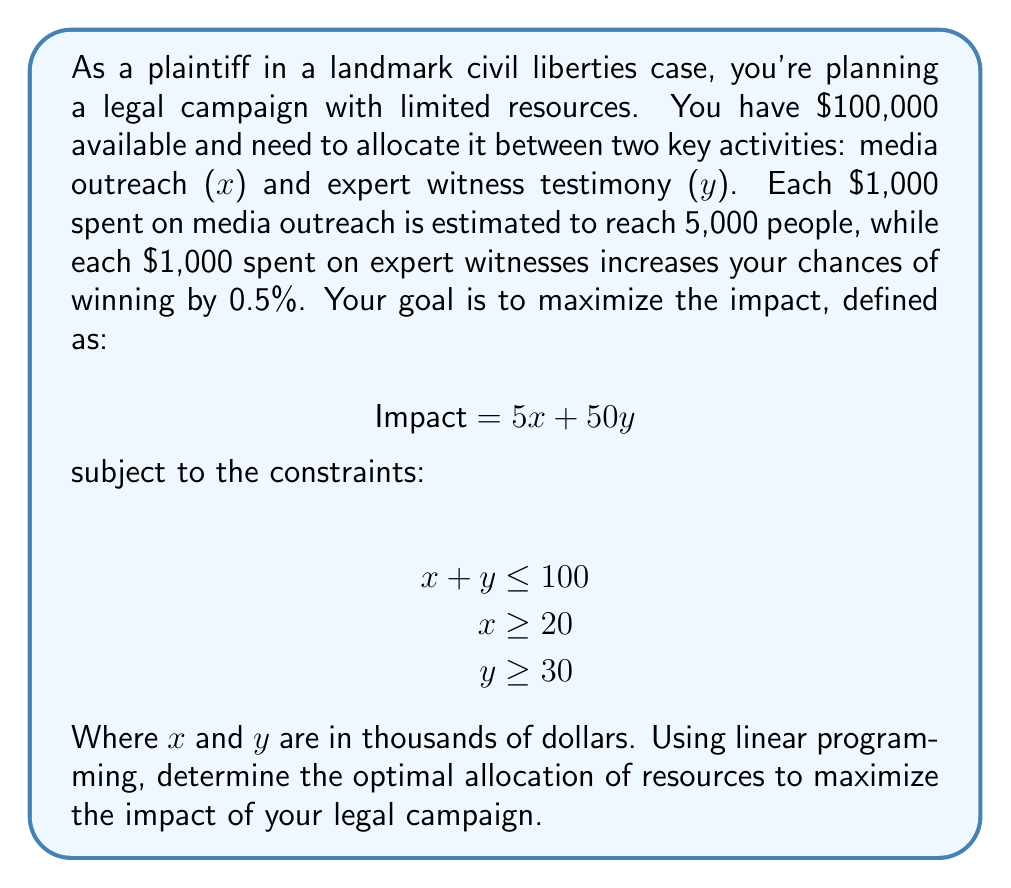Can you solve this math problem? To solve this linear programming problem, we'll use the graphical method:

1. Plot the constraints:
   - Budget constraint: $x + y = 100$
   - Minimum media outreach: $x = 20$
   - Minimum expert witness: $y = 30$

2. Identify the feasible region:
   The feasible region is the area that satisfies all constraints.

3. Find the corners of the feasible region:
   A: (20, 30)
   B: (20, 80)
   C: (70, 30)

4. Evaluate the objective function at each corner:
   $$ \text{Impact} = 5x + 50y $$
   
   A: $5(20) + 50(30) = 1600$
   B: $5(20) + 50(80) = 4100$
   C: $5(70) + 50(30) = 1850$

5. The maximum impact occurs at point B (20, 80).

Therefore, the optimal allocation is:
- Media outreach: $20,000
- Expert witness testimony: $80,000

This allocation maximizes the impact at 4100 units.
Answer: $20,000 on media outreach, $80,000 on expert witnesses 